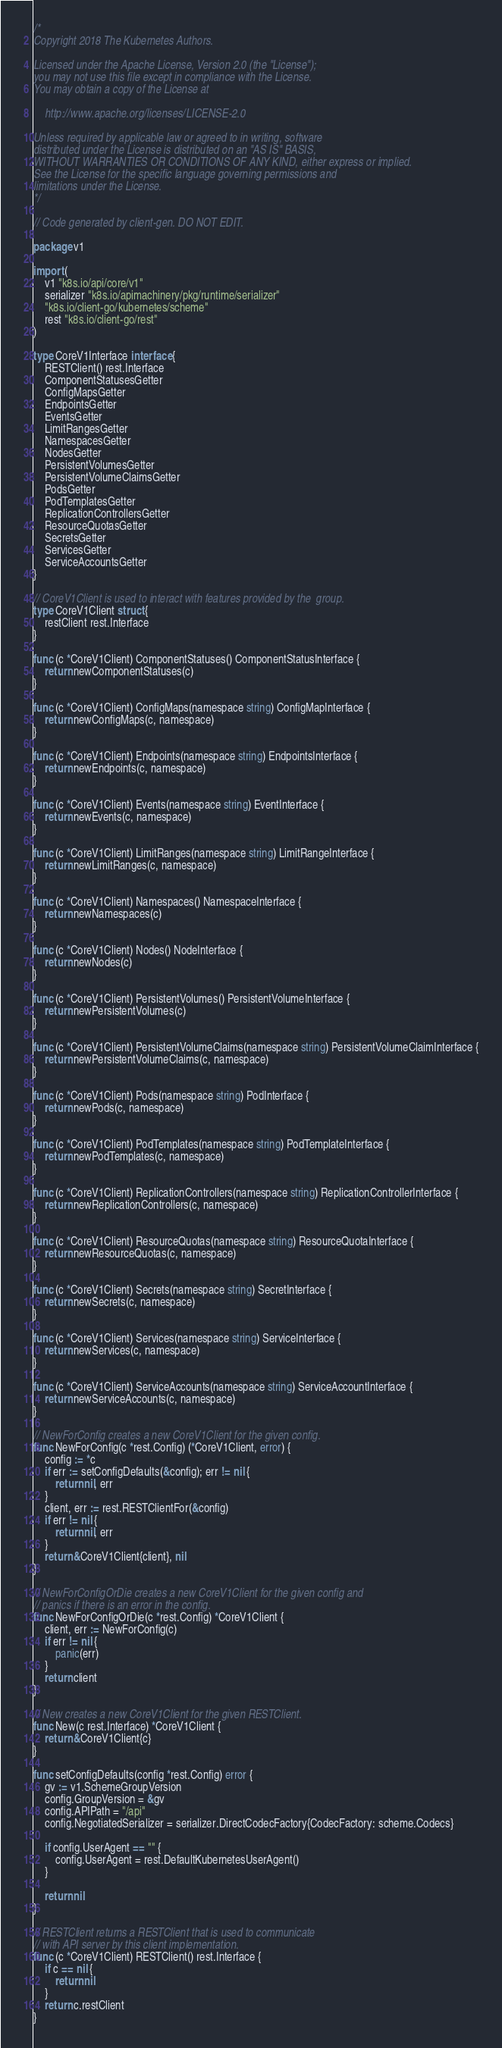Convert code to text. <code><loc_0><loc_0><loc_500><loc_500><_Go_>/*
Copyright 2018 The Kubernetes Authors.

Licensed under the Apache License, Version 2.0 (the "License");
you may not use this file except in compliance with the License.
You may obtain a copy of the License at

    http://www.apache.org/licenses/LICENSE-2.0

Unless required by applicable law or agreed to in writing, software
distributed under the License is distributed on an "AS IS" BASIS,
WITHOUT WARRANTIES OR CONDITIONS OF ANY KIND, either express or implied.
See the License for the specific language governing permissions and
limitations under the License.
*/

// Code generated by client-gen. DO NOT EDIT.

package v1

import (
	v1 "k8s.io/api/core/v1"
	serializer "k8s.io/apimachinery/pkg/runtime/serializer"
	"k8s.io/client-go/kubernetes/scheme"
	rest "k8s.io/client-go/rest"
)

type CoreV1Interface interface {
	RESTClient() rest.Interface
	ComponentStatusesGetter
	ConfigMapsGetter
	EndpointsGetter
	EventsGetter
	LimitRangesGetter
	NamespacesGetter
	NodesGetter
	PersistentVolumesGetter
	PersistentVolumeClaimsGetter
	PodsGetter
	PodTemplatesGetter
	ReplicationControllersGetter
	ResourceQuotasGetter
	SecretsGetter
	ServicesGetter
	ServiceAccountsGetter
}

// CoreV1Client is used to interact with features provided by the  group.
type CoreV1Client struct {
	restClient rest.Interface
}

func (c *CoreV1Client) ComponentStatuses() ComponentStatusInterface {
	return newComponentStatuses(c)
}

func (c *CoreV1Client) ConfigMaps(namespace string) ConfigMapInterface {
	return newConfigMaps(c, namespace)
}

func (c *CoreV1Client) Endpoints(namespace string) EndpointsInterface {
	return newEndpoints(c, namespace)
}

func (c *CoreV1Client) Events(namespace string) EventInterface {
	return newEvents(c, namespace)
}

func (c *CoreV1Client) LimitRanges(namespace string) LimitRangeInterface {
	return newLimitRanges(c, namespace)
}

func (c *CoreV1Client) Namespaces() NamespaceInterface {
	return newNamespaces(c)
}

func (c *CoreV1Client) Nodes() NodeInterface {
	return newNodes(c)
}

func (c *CoreV1Client) PersistentVolumes() PersistentVolumeInterface {
	return newPersistentVolumes(c)
}

func (c *CoreV1Client) PersistentVolumeClaims(namespace string) PersistentVolumeClaimInterface {
	return newPersistentVolumeClaims(c, namespace)
}

func (c *CoreV1Client) Pods(namespace string) PodInterface {
	return newPods(c, namespace)
}

func (c *CoreV1Client) PodTemplates(namespace string) PodTemplateInterface {
	return newPodTemplates(c, namespace)
}

func (c *CoreV1Client) ReplicationControllers(namespace string) ReplicationControllerInterface {
	return newReplicationControllers(c, namespace)
}

func (c *CoreV1Client) ResourceQuotas(namespace string) ResourceQuotaInterface {
	return newResourceQuotas(c, namespace)
}

func (c *CoreV1Client) Secrets(namespace string) SecretInterface {
	return newSecrets(c, namespace)
}

func (c *CoreV1Client) Services(namespace string) ServiceInterface {
	return newServices(c, namespace)
}

func (c *CoreV1Client) ServiceAccounts(namespace string) ServiceAccountInterface {
	return newServiceAccounts(c, namespace)
}

// NewForConfig creates a new CoreV1Client for the given config.
func NewForConfig(c *rest.Config) (*CoreV1Client, error) {
	config := *c
	if err := setConfigDefaults(&config); err != nil {
		return nil, err
	}
	client, err := rest.RESTClientFor(&config)
	if err != nil {
		return nil, err
	}
	return &CoreV1Client{client}, nil
}

// NewForConfigOrDie creates a new CoreV1Client for the given config and
// panics if there is an error in the config.
func NewForConfigOrDie(c *rest.Config) *CoreV1Client {
	client, err := NewForConfig(c)
	if err != nil {
		panic(err)
	}
	return client
}

// New creates a new CoreV1Client for the given RESTClient.
func New(c rest.Interface) *CoreV1Client {
	return &CoreV1Client{c}
}

func setConfigDefaults(config *rest.Config) error {
	gv := v1.SchemeGroupVersion
	config.GroupVersion = &gv
	config.APIPath = "/api"
	config.NegotiatedSerializer = serializer.DirectCodecFactory{CodecFactory: scheme.Codecs}

	if config.UserAgent == "" {
		config.UserAgent = rest.DefaultKubernetesUserAgent()
	}

	return nil
}

// RESTClient returns a RESTClient that is used to communicate
// with API server by this client implementation.
func (c *CoreV1Client) RESTClient() rest.Interface {
	if c == nil {
		return nil
	}
	return c.restClient
}
</code> 